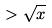Convert formula to latex. <formula><loc_0><loc_0><loc_500><loc_500>> \sqrt { x }</formula> 